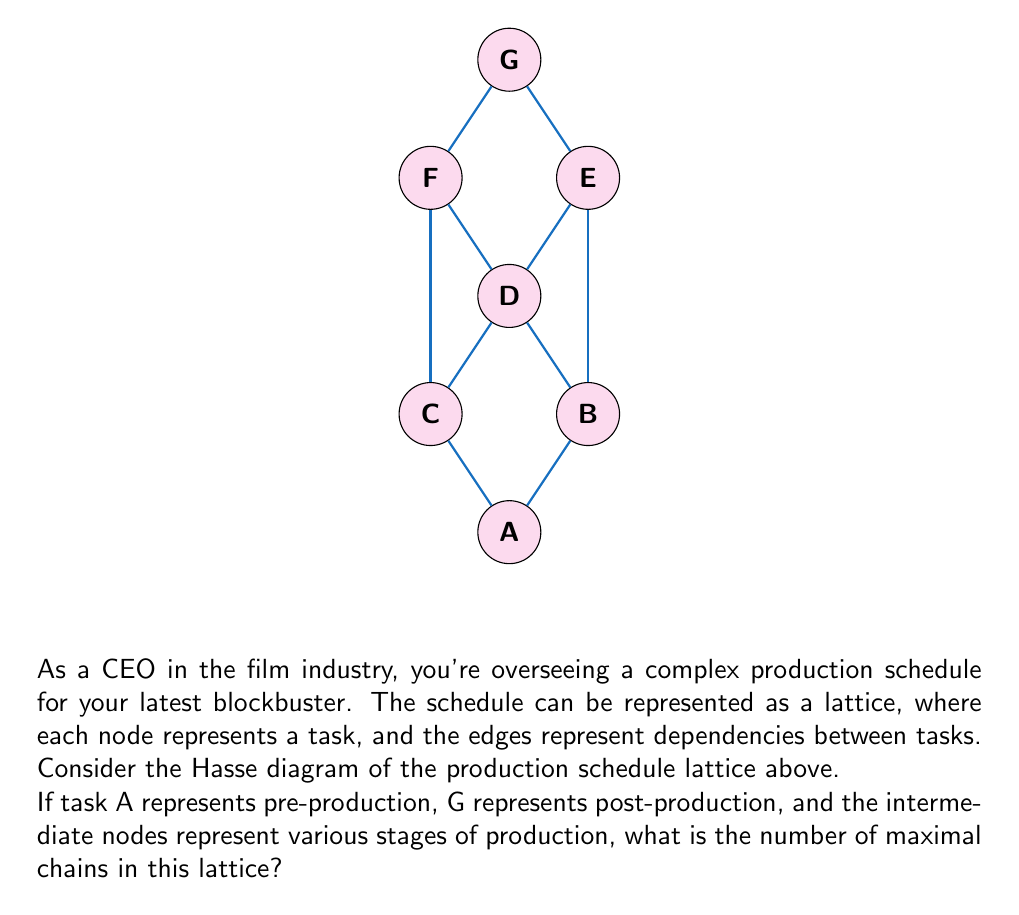Help me with this question. To solve this problem, we need to understand the concept of maximal chains in a lattice and analyze the given Hasse diagram. Let's break it down step-by-step:

1) A chain in a lattice is a totally ordered subset of elements. A maximal chain is a chain that cannot be extended by including any other element of the lattice.

2) In this lattice, a maximal chain will start from the bottom element (A) and end at the top element (G), including all elements in between that form a path from A to G.

3) Let's identify all possible paths from A to G:

   Path 1: A → B → D → E → G
   Path 2: A → B → D → F → G
   Path 3: A → C → D → E → G
   Path 4: A → C → D → F → G

4) Each of these paths represents a maximal chain because:
   - They start at the minimum element (A) and end at the maximum element (G)
   - They include all possible elements along the way
   - They cannot be extended by including any other element

5) Therefore, we can conclude that there are 4 maximal chains in this lattice.

This analysis helps in understanding the structure of the production schedule, where each maximal chain represents a possible sequence of tasks from pre-production to post-production. As a CEO, this information can be valuable for resource allocation and risk management in film production.
Answer: 4 